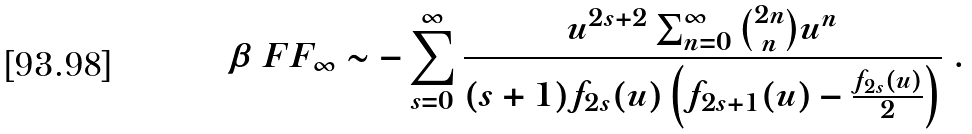<formula> <loc_0><loc_0><loc_500><loc_500>\beta \ F F _ { \infty } \sim - \sum _ { s = 0 } ^ { \infty } \frac { u ^ { 2 s + 2 } \sum _ { n = 0 } ^ { \infty } \binom { 2 n } { n } u ^ { n } } { ( s + 1 ) f _ { 2 s } ( u ) \left ( f _ { 2 s + 1 } ( u ) - \frac { f _ { 2 s } ( u ) } { 2 } \right ) } \ .</formula> 